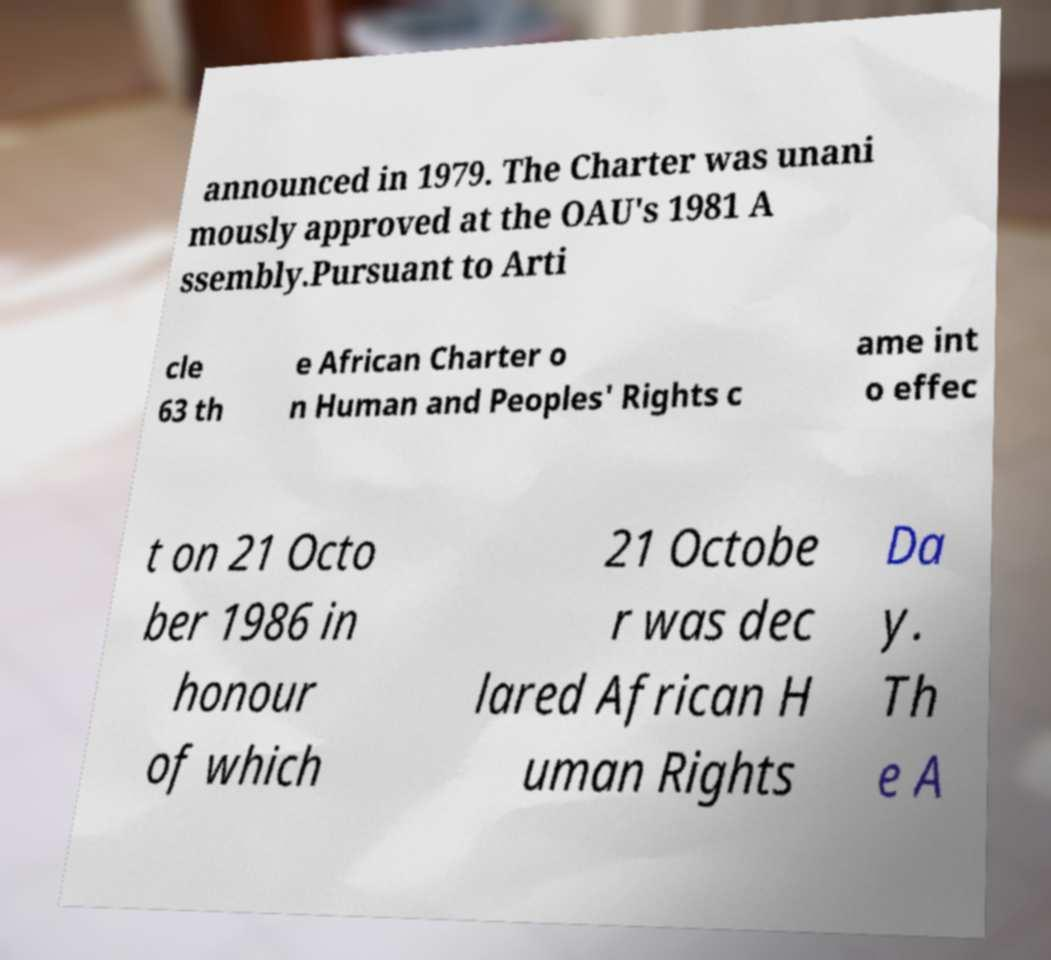Please identify and transcribe the text found in this image. announced in 1979. The Charter was unani mously approved at the OAU's 1981 A ssembly.Pursuant to Arti cle 63 th e African Charter o n Human and Peoples' Rights c ame int o effec t on 21 Octo ber 1986 in honour of which 21 Octobe r was dec lared African H uman Rights Da y. Th e A 